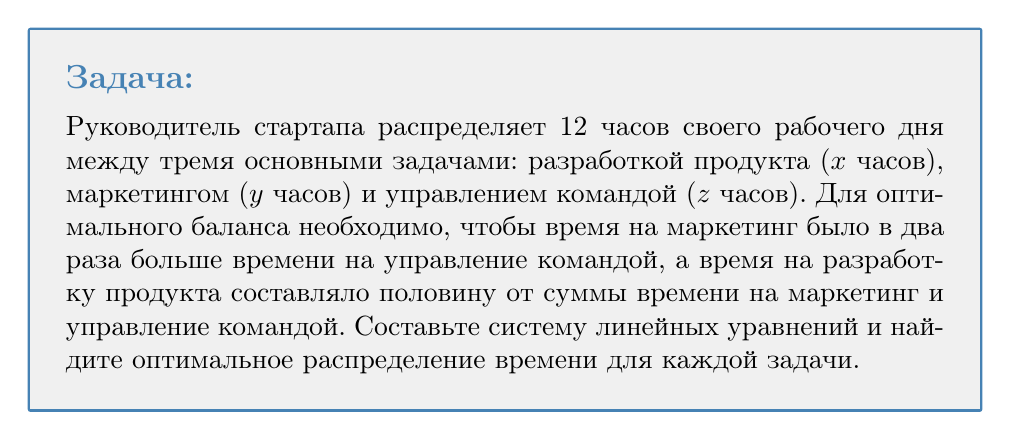Can you solve this math problem? Шаг 1: Определим переменные
x - время на разработку продукта
y - время на маркетинг
z - время на управление командой

Шаг 2: Составим систему линейных уравнений
1) Общее время: $x + y + z = 12$
2) Маркетинг в два раза больше управления: $y = 2z$
3) Разработка - половина от суммы маркетинга и управления: $x = \frac{1}{2}(y + z)$

Шаг 3: Решим систему уравнений
Из уравнения 2: $y = 2z$
Подставим в уравнение 3: $x = \frac{1}{2}(2z + z) = \frac{3z}{2}$

Теперь подставим выражения для x и y в уравнение 1:
$\frac{3z}{2} + 2z + z = 12$
$\frac{3z}{2} + 3z = 12$
$\frac{9z}{2} = 12$
$z = \frac{24}{9} = \frac{8}{3}$

Шаг 4: Найдем значения для y и x
$y = 2z = 2 \cdot \frac{8}{3} = \frac{16}{3}$
$x = \frac{3z}{2} = \frac{3}{2} \cdot \frac{8}{3} = 4$

Шаг 5: Проверка
$x + y + z = 4 + \frac{16}{3} + \frac{8}{3} = 4 + \frac{24}{3} = 4 + 8 = 12$

Итак, оптимальное распределение времени:
Разработка продукта (x): 4 часа
Маркетинг (y): $\frac{16}{3}$ часа (примерно 5 часов 20 минут)
Управление командой (z): $\frac{8}{3}$ часа (примерно 2 часа 40 минут)
Answer: x = 4, y = $\frac{16}{3}$, z = $\frac{8}{3}$ 